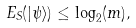Convert formula to latex. <formula><loc_0><loc_0><loc_500><loc_500>E _ { S } ( | \psi \rangle ) \leq \log _ { 2 } ( m ) ,</formula> 